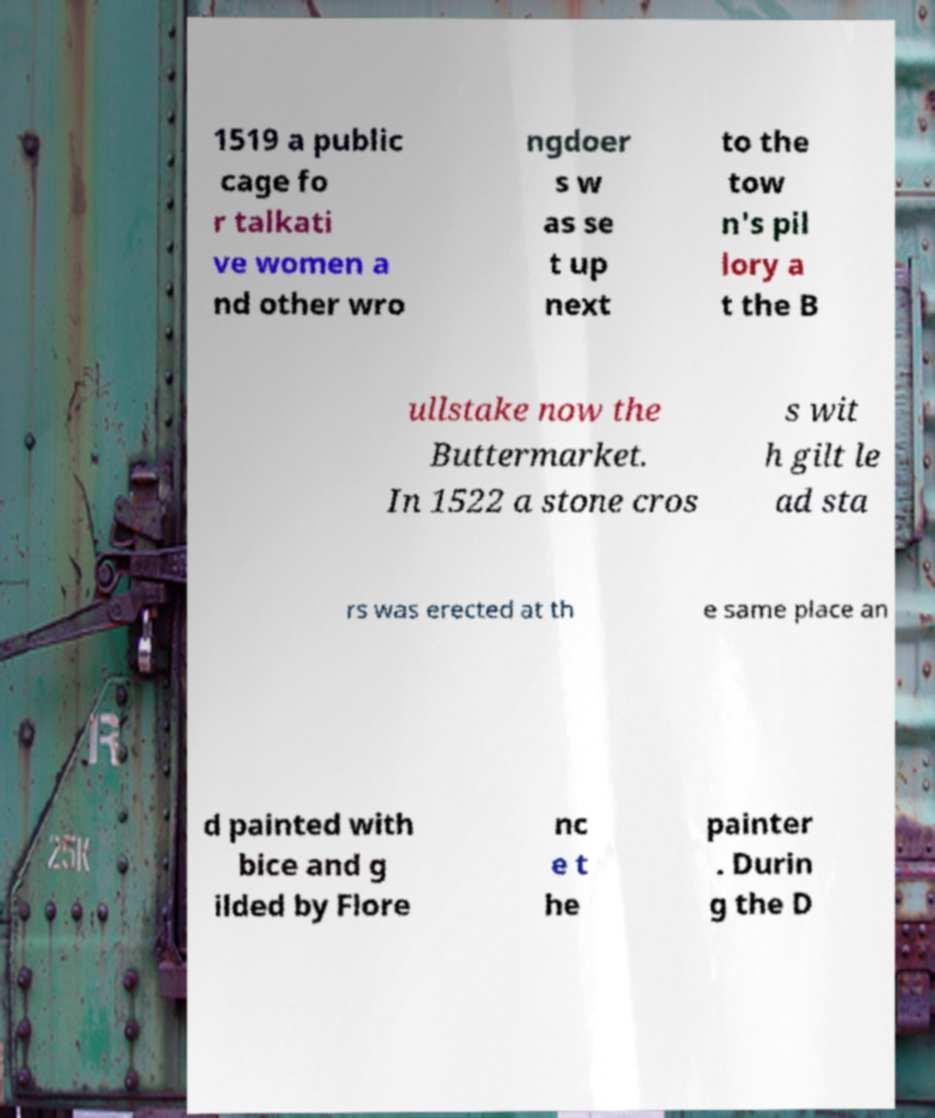Can you read and provide the text displayed in the image?This photo seems to have some interesting text. Can you extract and type it out for me? 1519 a public cage fo r talkati ve women a nd other wro ngdoer s w as se t up next to the tow n's pil lory a t the B ullstake now the Buttermarket. In 1522 a stone cros s wit h gilt le ad sta rs was erected at th e same place an d painted with bice and g ilded by Flore nc e t he painter . Durin g the D 